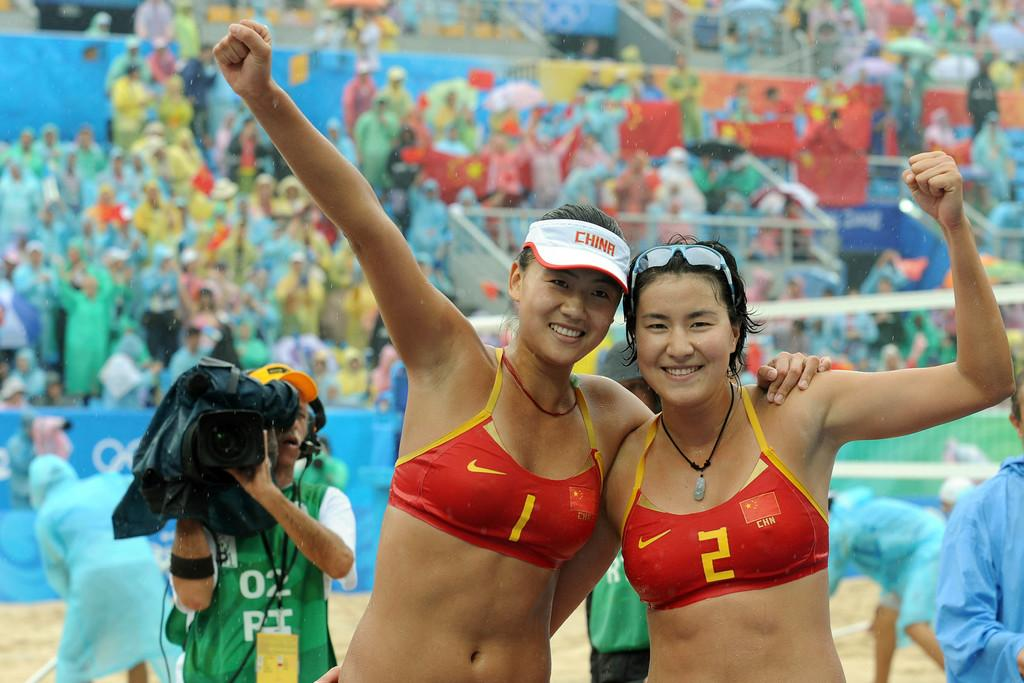<image>
Share a concise interpretation of the image provided. the number 2 is on the shirt of a person 